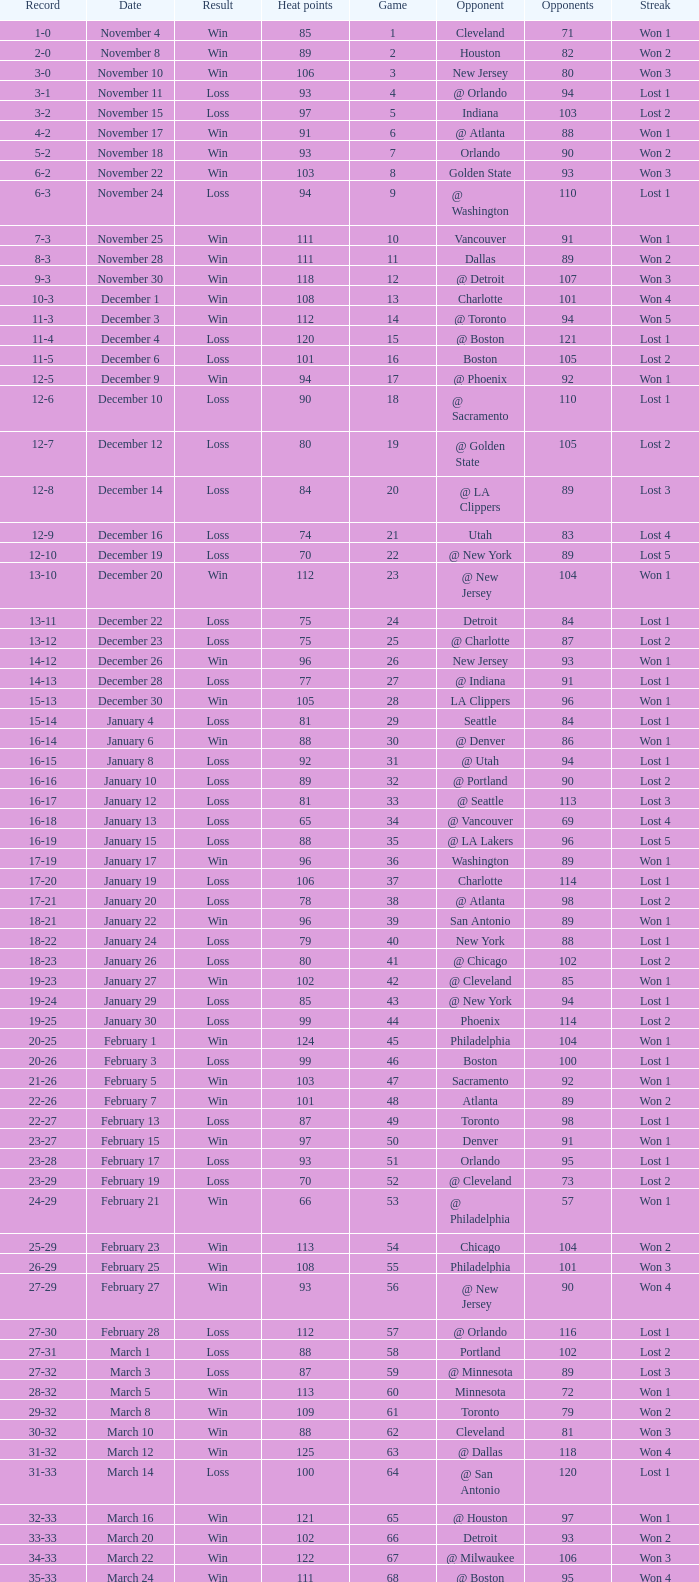What is Heat Points, when Game is less than 80, and when Date is "April 26 (First Round)"? 85.0. 